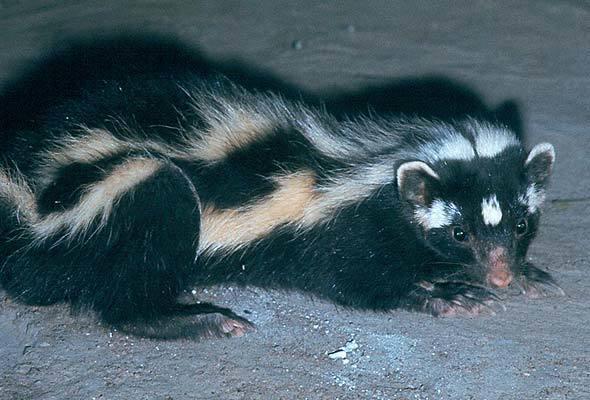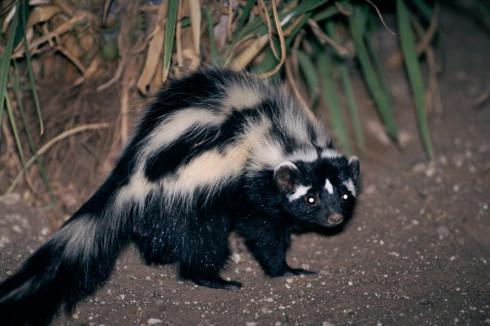The first image is the image on the left, the second image is the image on the right. For the images displayed, is the sentence "The back of one of the skunks is arched upwards." factually correct? Answer yes or no. Yes. The first image is the image on the left, the second image is the image on the right. For the images displayed, is the sentence "Both skunks are pointed in the same direction." factually correct? Answer yes or no. Yes. 